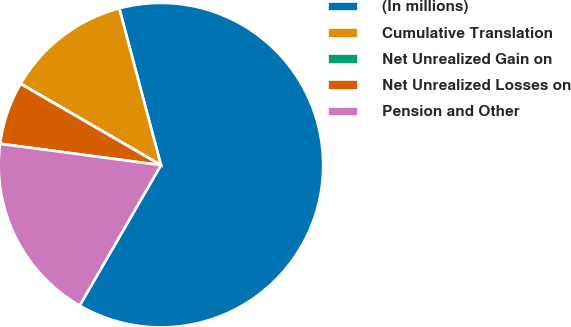Convert chart to OTSL. <chart><loc_0><loc_0><loc_500><loc_500><pie_chart><fcel>(In millions)<fcel>Cumulative Translation<fcel>Net Unrealized Gain on<fcel>Net Unrealized Losses on<fcel>Pension and Other<nl><fcel>62.49%<fcel>12.5%<fcel>0.01%<fcel>6.25%<fcel>18.75%<nl></chart> 